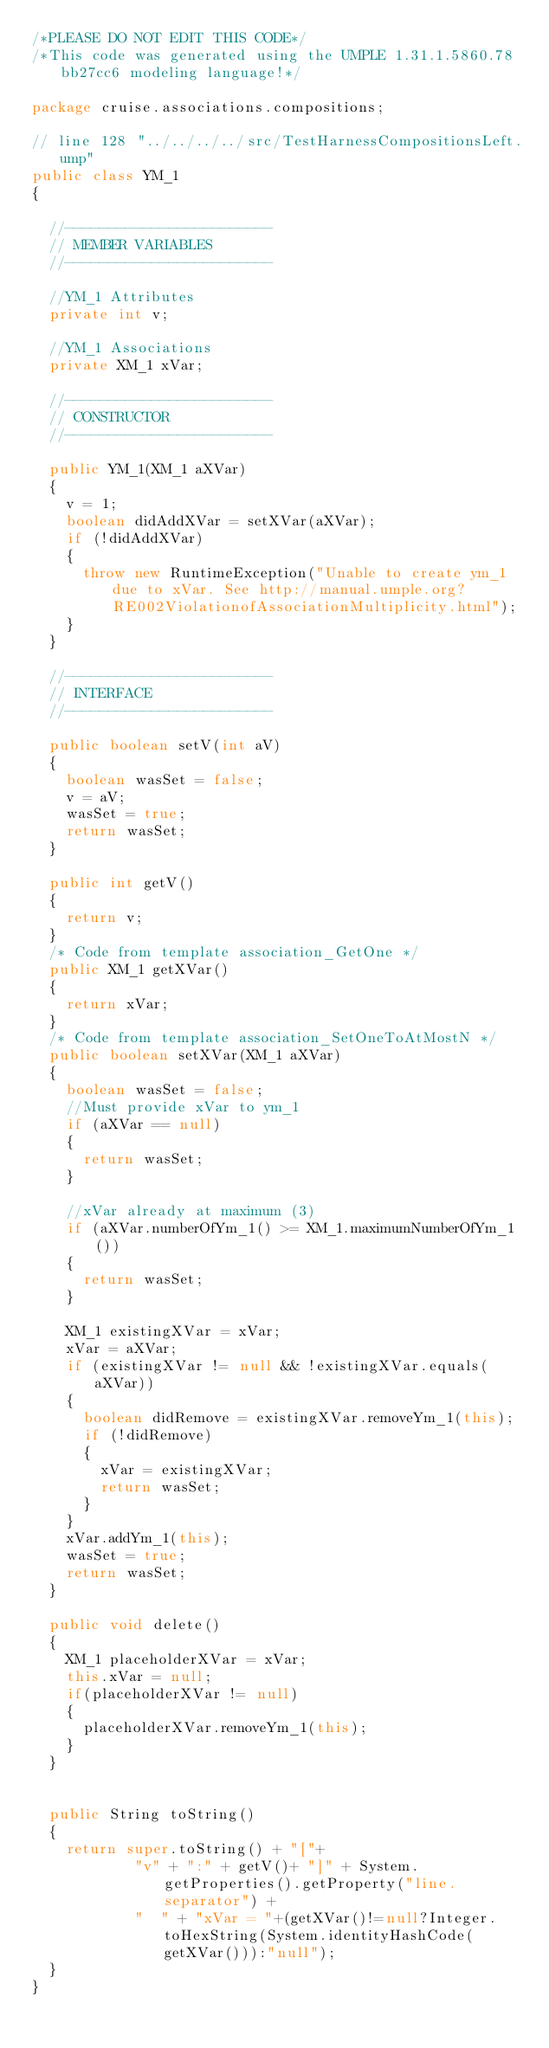<code> <loc_0><loc_0><loc_500><loc_500><_Java_>/*PLEASE DO NOT EDIT THIS CODE*/
/*This code was generated using the UMPLE 1.31.1.5860.78bb27cc6 modeling language!*/

package cruise.associations.compositions;

// line 128 "../../../../src/TestHarnessCompositionsLeft.ump"
public class YM_1
{

  //------------------------
  // MEMBER VARIABLES
  //------------------------

  //YM_1 Attributes
  private int v;

  //YM_1 Associations
  private XM_1 xVar;

  //------------------------
  // CONSTRUCTOR
  //------------------------

  public YM_1(XM_1 aXVar)
  {
    v = 1;
    boolean didAddXVar = setXVar(aXVar);
    if (!didAddXVar)
    {
      throw new RuntimeException("Unable to create ym_1 due to xVar. See http://manual.umple.org?RE002ViolationofAssociationMultiplicity.html");
    }
  }

  //------------------------
  // INTERFACE
  //------------------------

  public boolean setV(int aV)
  {
    boolean wasSet = false;
    v = aV;
    wasSet = true;
    return wasSet;
  }

  public int getV()
  {
    return v;
  }
  /* Code from template association_GetOne */
  public XM_1 getXVar()
  {
    return xVar;
  }
  /* Code from template association_SetOneToAtMostN */
  public boolean setXVar(XM_1 aXVar)
  {
    boolean wasSet = false;
    //Must provide xVar to ym_1
    if (aXVar == null)
    {
      return wasSet;
    }

    //xVar already at maximum (3)
    if (aXVar.numberOfYm_1() >= XM_1.maximumNumberOfYm_1())
    {
      return wasSet;
    }
    
    XM_1 existingXVar = xVar;
    xVar = aXVar;
    if (existingXVar != null && !existingXVar.equals(aXVar))
    {
      boolean didRemove = existingXVar.removeYm_1(this);
      if (!didRemove)
      {
        xVar = existingXVar;
        return wasSet;
      }
    }
    xVar.addYm_1(this);
    wasSet = true;
    return wasSet;
  }

  public void delete()
  {
    XM_1 placeholderXVar = xVar;
    this.xVar = null;
    if(placeholderXVar != null)
    {
      placeholderXVar.removeYm_1(this);
    }
  }


  public String toString()
  {
    return super.toString() + "["+
            "v" + ":" + getV()+ "]" + System.getProperties().getProperty("line.separator") +
            "  " + "xVar = "+(getXVar()!=null?Integer.toHexString(System.identityHashCode(getXVar())):"null");
  }
}</code> 